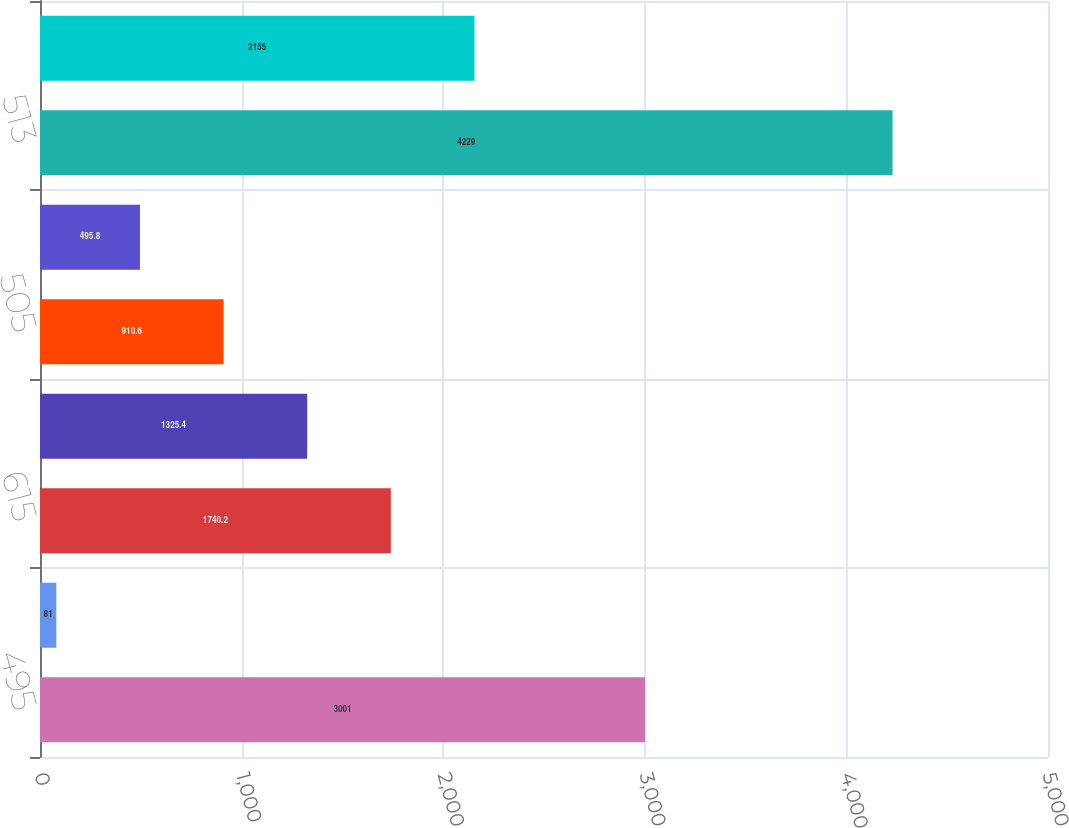<chart> <loc_0><loc_0><loc_500><loc_500><bar_chart><fcel>495<fcel>515<fcel>615<fcel>504<fcel>505<fcel>812<fcel>513<fcel>(015)<nl><fcel>3001<fcel>81<fcel>1740.2<fcel>1325.4<fcel>910.6<fcel>495.8<fcel>4229<fcel>2155<nl></chart> 